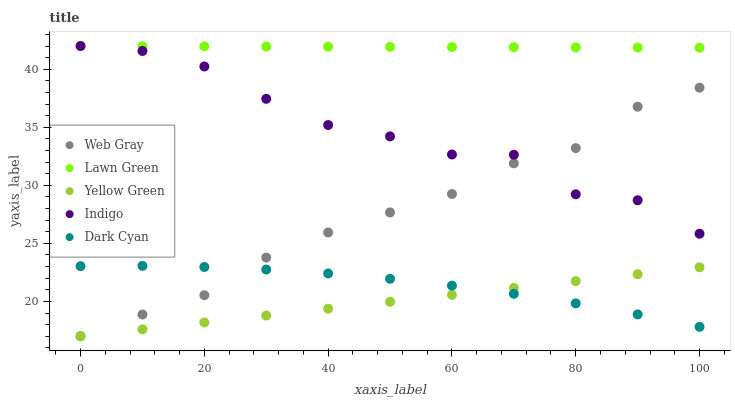Does Yellow Green have the minimum area under the curve?
Answer yes or no. Yes. Does Lawn Green have the maximum area under the curve?
Answer yes or no. Yes. Does Web Gray have the minimum area under the curve?
Answer yes or no. No. Does Web Gray have the maximum area under the curve?
Answer yes or no. No. Is Lawn Green the smoothest?
Answer yes or no. Yes. Is Indigo the roughest?
Answer yes or no. Yes. Is Web Gray the smoothest?
Answer yes or no. No. Is Web Gray the roughest?
Answer yes or no. No. Does Web Gray have the lowest value?
Answer yes or no. Yes. Does Lawn Green have the lowest value?
Answer yes or no. No. Does Indigo have the highest value?
Answer yes or no. Yes. Does Web Gray have the highest value?
Answer yes or no. No. Is Dark Cyan less than Lawn Green?
Answer yes or no. Yes. Is Lawn Green greater than Web Gray?
Answer yes or no. Yes. Does Web Gray intersect Yellow Green?
Answer yes or no. Yes. Is Web Gray less than Yellow Green?
Answer yes or no. No. Is Web Gray greater than Yellow Green?
Answer yes or no. No. Does Dark Cyan intersect Lawn Green?
Answer yes or no. No. 